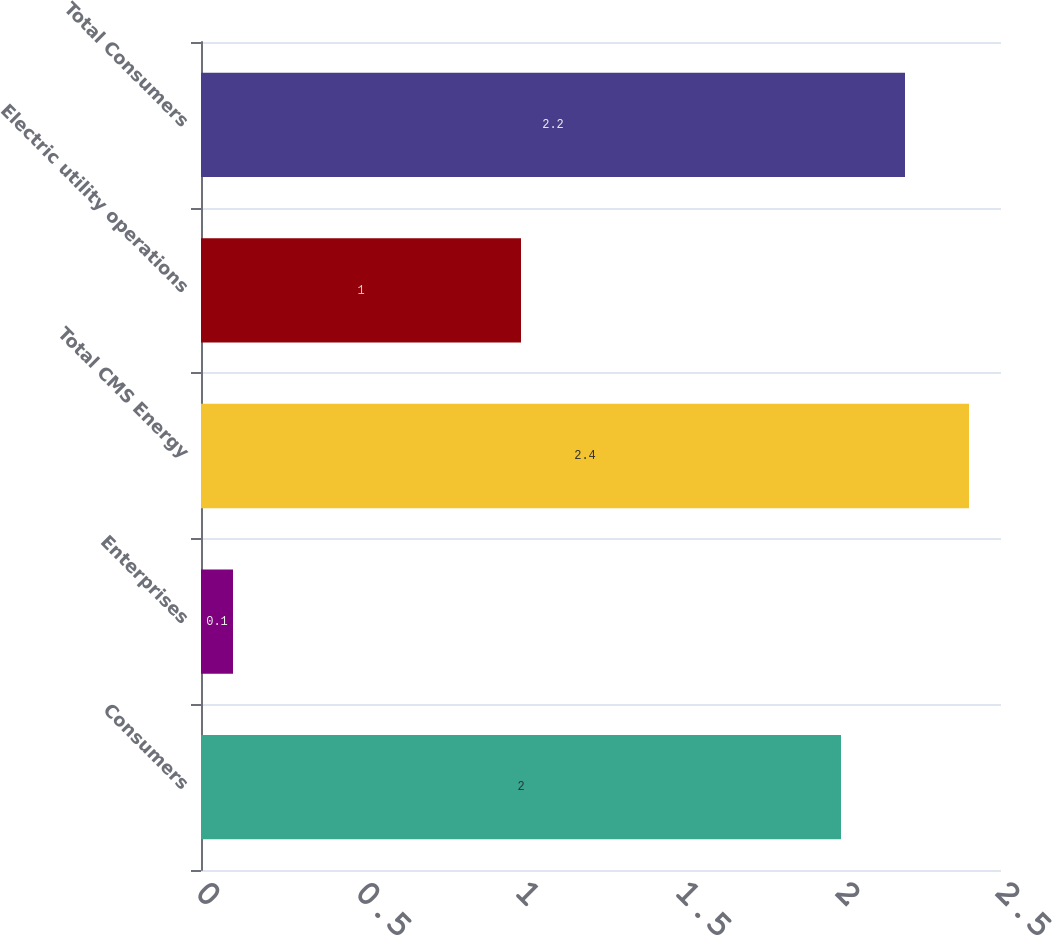Convert chart to OTSL. <chart><loc_0><loc_0><loc_500><loc_500><bar_chart><fcel>Consumers<fcel>Enterprises<fcel>Total CMS Energy<fcel>Electric utility operations<fcel>Total Consumers<nl><fcel>2<fcel>0.1<fcel>2.4<fcel>1<fcel>2.2<nl></chart> 